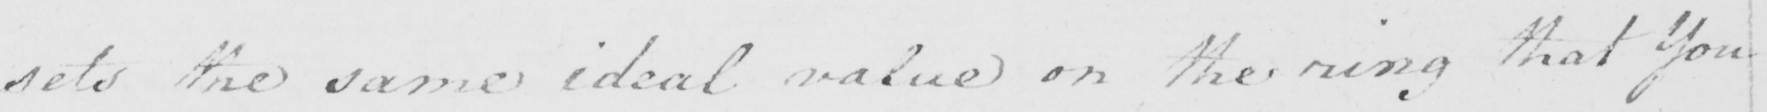What is written in this line of handwriting? sets the same ideal value on the ring that You 